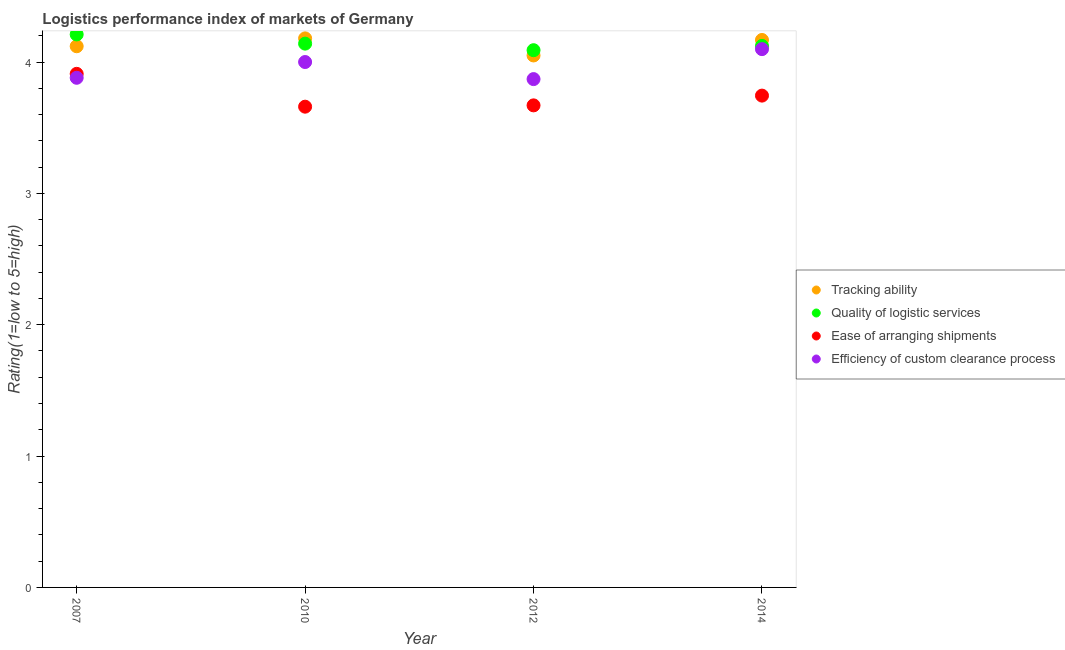Is the number of dotlines equal to the number of legend labels?
Offer a very short reply. Yes. What is the lpi rating of ease of arranging shipments in 2014?
Provide a short and direct response. 3.74. Across all years, what is the maximum lpi rating of ease of arranging shipments?
Offer a very short reply. 3.91. Across all years, what is the minimum lpi rating of ease of arranging shipments?
Make the answer very short. 3.66. In which year was the lpi rating of tracking ability minimum?
Make the answer very short. 2012. What is the total lpi rating of tracking ability in the graph?
Offer a very short reply. 16.52. What is the difference between the lpi rating of quality of logistic services in 2010 and that in 2012?
Give a very brief answer. 0.05. What is the difference between the lpi rating of ease of arranging shipments in 2007 and the lpi rating of tracking ability in 2010?
Make the answer very short. -0.27. What is the average lpi rating of quality of logistic services per year?
Give a very brief answer. 4.14. In the year 2012, what is the difference between the lpi rating of tracking ability and lpi rating of quality of logistic services?
Ensure brevity in your answer.  -0.04. What is the ratio of the lpi rating of ease of arranging shipments in 2007 to that in 2012?
Your answer should be very brief. 1.07. Is the difference between the lpi rating of efficiency of custom clearance process in 2007 and 2010 greater than the difference between the lpi rating of tracking ability in 2007 and 2010?
Provide a short and direct response. No. What is the difference between the highest and the second highest lpi rating of quality of logistic services?
Give a very brief answer. 0.07. What is the difference between the highest and the lowest lpi rating of quality of logistic services?
Your response must be concise. 0.12. In how many years, is the lpi rating of tracking ability greater than the average lpi rating of tracking ability taken over all years?
Make the answer very short. 2. Is the sum of the lpi rating of ease of arranging shipments in 2010 and 2014 greater than the maximum lpi rating of efficiency of custom clearance process across all years?
Provide a short and direct response. Yes. Is it the case that in every year, the sum of the lpi rating of tracking ability and lpi rating of quality of logistic services is greater than the lpi rating of ease of arranging shipments?
Make the answer very short. Yes. Does the lpi rating of ease of arranging shipments monotonically increase over the years?
Provide a succinct answer. No. How many dotlines are there?
Your answer should be very brief. 4. What is the difference between two consecutive major ticks on the Y-axis?
Keep it short and to the point. 1. Does the graph contain any zero values?
Give a very brief answer. No. Where does the legend appear in the graph?
Make the answer very short. Center right. How many legend labels are there?
Offer a very short reply. 4. How are the legend labels stacked?
Ensure brevity in your answer.  Vertical. What is the title of the graph?
Give a very brief answer. Logistics performance index of markets of Germany. What is the label or title of the Y-axis?
Provide a short and direct response. Rating(1=low to 5=high). What is the Rating(1=low to 5=high) of Tracking ability in 2007?
Offer a very short reply. 4.12. What is the Rating(1=low to 5=high) in Quality of logistic services in 2007?
Your answer should be very brief. 4.21. What is the Rating(1=low to 5=high) of Ease of arranging shipments in 2007?
Your answer should be very brief. 3.91. What is the Rating(1=low to 5=high) in Efficiency of custom clearance process in 2007?
Give a very brief answer. 3.88. What is the Rating(1=low to 5=high) of Tracking ability in 2010?
Provide a succinct answer. 4.18. What is the Rating(1=low to 5=high) in Quality of logistic services in 2010?
Offer a terse response. 4.14. What is the Rating(1=low to 5=high) in Ease of arranging shipments in 2010?
Make the answer very short. 3.66. What is the Rating(1=low to 5=high) of Tracking ability in 2012?
Your answer should be compact. 4.05. What is the Rating(1=low to 5=high) of Quality of logistic services in 2012?
Provide a succinct answer. 4.09. What is the Rating(1=low to 5=high) in Ease of arranging shipments in 2012?
Ensure brevity in your answer.  3.67. What is the Rating(1=low to 5=high) of Efficiency of custom clearance process in 2012?
Provide a short and direct response. 3.87. What is the Rating(1=low to 5=high) in Tracking ability in 2014?
Ensure brevity in your answer.  4.17. What is the Rating(1=low to 5=high) of Quality of logistic services in 2014?
Provide a succinct answer. 4.12. What is the Rating(1=low to 5=high) of Ease of arranging shipments in 2014?
Make the answer very short. 3.74. What is the Rating(1=low to 5=high) of Efficiency of custom clearance process in 2014?
Give a very brief answer. 4.1. Across all years, what is the maximum Rating(1=low to 5=high) in Tracking ability?
Keep it short and to the point. 4.18. Across all years, what is the maximum Rating(1=low to 5=high) in Quality of logistic services?
Make the answer very short. 4.21. Across all years, what is the maximum Rating(1=low to 5=high) of Ease of arranging shipments?
Your response must be concise. 3.91. Across all years, what is the maximum Rating(1=low to 5=high) in Efficiency of custom clearance process?
Keep it short and to the point. 4.1. Across all years, what is the minimum Rating(1=low to 5=high) in Tracking ability?
Ensure brevity in your answer.  4.05. Across all years, what is the minimum Rating(1=low to 5=high) of Quality of logistic services?
Give a very brief answer. 4.09. Across all years, what is the minimum Rating(1=low to 5=high) of Ease of arranging shipments?
Provide a short and direct response. 3.66. Across all years, what is the minimum Rating(1=low to 5=high) in Efficiency of custom clearance process?
Ensure brevity in your answer.  3.87. What is the total Rating(1=low to 5=high) in Tracking ability in the graph?
Your answer should be compact. 16.52. What is the total Rating(1=low to 5=high) of Quality of logistic services in the graph?
Give a very brief answer. 16.56. What is the total Rating(1=low to 5=high) of Ease of arranging shipments in the graph?
Offer a terse response. 14.98. What is the total Rating(1=low to 5=high) in Efficiency of custom clearance process in the graph?
Your answer should be very brief. 15.85. What is the difference between the Rating(1=low to 5=high) of Tracking ability in 2007 and that in 2010?
Your answer should be compact. -0.06. What is the difference between the Rating(1=low to 5=high) of Quality of logistic services in 2007 and that in 2010?
Give a very brief answer. 0.07. What is the difference between the Rating(1=low to 5=high) of Ease of arranging shipments in 2007 and that in 2010?
Your answer should be compact. 0.25. What is the difference between the Rating(1=low to 5=high) of Efficiency of custom clearance process in 2007 and that in 2010?
Provide a succinct answer. -0.12. What is the difference between the Rating(1=low to 5=high) of Tracking ability in 2007 and that in 2012?
Keep it short and to the point. 0.07. What is the difference between the Rating(1=low to 5=high) in Quality of logistic services in 2007 and that in 2012?
Your answer should be very brief. 0.12. What is the difference between the Rating(1=low to 5=high) in Ease of arranging shipments in 2007 and that in 2012?
Your response must be concise. 0.24. What is the difference between the Rating(1=low to 5=high) of Efficiency of custom clearance process in 2007 and that in 2012?
Provide a short and direct response. 0.01. What is the difference between the Rating(1=low to 5=high) in Tracking ability in 2007 and that in 2014?
Provide a short and direct response. -0.05. What is the difference between the Rating(1=low to 5=high) of Quality of logistic services in 2007 and that in 2014?
Give a very brief answer. 0.09. What is the difference between the Rating(1=low to 5=high) in Ease of arranging shipments in 2007 and that in 2014?
Provide a short and direct response. 0.17. What is the difference between the Rating(1=low to 5=high) in Efficiency of custom clearance process in 2007 and that in 2014?
Make the answer very short. -0.22. What is the difference between the Rating(1=low to 5=high) in Tracking ability in 2010 and that in 2012?
Make the answer very short. 0.13. What is the difference between the Rating(1=low to 5=high) in Ease of arranging shipments in 2010 and that in 2012?
Provide a succinct answer. -0.01. What is the difference between the Rating(1=low to 5=high) of Efficiency of custom clearance process in 2010 and that in 2012?
Make the answer very short. 0.13. What is the difference between the Rating(1=low to 5=high) of Tracking ability in 2010 and that in 2014?
Make the answer very short. 0.01. What is the difference between the Rating(1=low to 5=high) in Quality of logistic services in 2010 and that in 2014?
Offer a terse response. 0.02. What is the difference between the Rating(1=low to 5=high) in Ease of arranging shipments in 2010 and that in 2014?
Keep it short and to the point. -0.08. What is the difference between the Rating(1=low to 5=high) of Efficiency of custom clearance process in 2010 and that in 2014?
Provide a short and direct response. -0.1. What is the difference between the Rating(1=low to 5=high) of Tracking ability in 2012 and that in 2014?
Provide a short and direct response. -0.12. What is the difference between the Rating(1=low to 5=high) of Quality of logistic services in 2012 and that in 2014?
Your answer should be compact. -0.03. What is the difference between the Rating(1=low to 5=high) in Ease of arranging shipments in 2012 and that in 2014?
Make the answer very short. -0.07. What is the difference between the Rating(1=low to 5=high) in Efficiency of custom clearance process in 2012 and that in 2014?
Offer a terse response. -0.23. What is the difference between the Rating(1=low to 5=high) in Tracking ability in 2007 and the Rating(1=low to 5=high) in Quality of logistic services in 2010?
Your response must be concise. -0.02. What is the difference between the Rating(1=low to 5=high) of Tracking ability in 2007 and the Rating(1=low to 5=high) of Ease of arranging shipments in 2010?
Your response must be concise. 0.46. What is the difference between the Rating(1=low to 5=high) in Tracking ability in 2007 and the Rating(1=low to 5=high) in Efficiency of custom clearance process in 2010?
Your answer should be very brief. 0.12. What is the difference between the Rating(1=low to 5=high) in Quality of logistic services in 2007 and the Rating(1=low to 5=high) in Ease of arranging shipments in 2010?
Offer a terse response. 0.55. What is the difference between the Rating(1=low to 5=high) of Quality of logistic services in 2007 and the Rating(1=low to 5=high) of Efficiency of custom clearance process in 2010?
Provide a succinct answer. 0.21. What is the difference between the Rating(1=low to 5=high) of Ease of arranging shipments in 2007 and the Rating(1=low to 5=high) of Efficiency of custom clearance process in 2010?
Your answer should be compact. -0.09. What is the difference between the Rating(1=low to 5=high) in Tracking ability in 2007 and the Rating(1=low to 5=high) in Ease of arranging shipments in 2012?
Your response must be concise. 0.45. What is the difference between the Rating(1=low to 5=high) in Tracking ability in 2007 and the Rating(1=low to 5=high) in Efficiency of custom clearance process in 2012?
Keep it short and to the point. 0.25. What is the difference between the Rating(1=low to 5=high) in Quality of logistic services in 2007 and the Rating(1=low to 5=high) in Ease of arranging shipments in 2012?
Offer a terse response. 0.54. What is the difference between the Rating(1=low to 5=high) in Quality of logistic services in 2007 and the Rating(1=low to 5=high) in Efficiency of custom clearance process in 2012?
Provide a short and direct response. 0.34. What is the difference between the Rating(1=low to 5=high) in Tracking ability in 2007 and the Rating(1=low to 5=high) in Quality of logistic services in 2014?
Keep it short and to the point. -0. What is the difference between the Rating(1=low to 5=high) in Tracking ability in 2007 and the Rating(1=low to 5=high) in Ease of arranging shipments in 2014?
Your answer should be very brief. 0.38. What is the difference between the Rating(1=low to 5=high) in Tracking ability in 2007 and the Rating(1=low to 5=high) in Efficiency of custom clearance process in 2014?
Offer a terse response. 0.02. What is the difference between the Rating(1=low to 5=high) in Quality of logistic services in 2007 and the Rating(1=low to 5=high) in Ease of arranging shipments in 2014?
Provide a short and direct response. 0.47. What is the difference between the Rating(1=low to 5=high) of Quality of logistic services in 2007 and the Rating(1=low to 5=high) of Efficiency of custom clearance process in 2014?
Provide a short and direct response. 0.11. What is the difference between the Rating(1=low to 5=high) in Ease of arranging shipments in 2007 and the Rating(1=low to 5=high) in Efficiency of custom clearance process in 2014?
Give a very brief answer. -0.19. What is the difference between the Rating(1=low to 5=high) in Tracking ability in 2010 and the Rating(1=low to 5=high) in Quality of logistic services in 2012?
Make the answer very short. 0.09. What is the difference between the Rating(1=low to 5=high) in Tracking ability in 2010 and the Rating(1=low to 5=high) in Ease of arranging shipments in 2012?
Offer a very short reply. 0.51. What is the difference between the Rating(1=low to 5=high) of Tracking ability in 2010 and the Rating(1=low to 5=high) of Efficiency of custom clearance process in 2012?
Your answer should be compact. 0.31. What is the difference between the Rating(1=low to 5=high) of Quality of logistic services in 2010 and the Rating(1=low to 5=high) of Ease of arranging shipments in 2012?
Your answer should be very brief. 0.47. What is the difference between the Rating(1=low to 5=high) of Quality of logistic services in 2010 and the Rating(1=low to 5=high) of Efficiency of custom clearance process in 2012?
Keep it short and to the point. 0.27. What is the difference between the Rating(1=low to 5=high) of Ease of arranging shipments in 2010 and the Rating(1=low to 5=high) of Efficiency of custom clearance process in 2012?
Make the answer very short. -0.21. What is the difference between the Rating(1=low to 5=high) of Tracking ability in 2010 and the Rating(1=low to 5=high) of Quality of logistic services in 2014?
Provide a short and direct response. 0.06. What is the difference between the Rating(1=low to 5=high) of Tracking ability in 2010 and the Rating(1=low to 5=high) of Ease of arranging shipments in 2014?
Ensure brevity in your answer.  0.44. What is the difference between the Rating(1=low to 5=high) in Tracking ability in 2010 and the Rating(1=low to 5=high) in Efficiency of custom clearance process in 2014?
Your answer should be very brief. 0.08. What is the difference between the Rating(1=low to 5=high) in Quality of logistic services in 2010 and the Rating(1=low to 5=high) in Ease of arranging shipments in 2014?
Provide a short and direct response. 0.4. What is the difference between the Rating(1=low to 5=high) of Quality of logistic services in 2010 and the Rating(1=low to 5=high) of Efficiency of custom clearance process in 2014?
Make the answer very short. 0.04. What is the difference between the Rating(1=low to 5=high) of Ease of arranging shipments in 2010 and the Rating(1=low to 5=high) of Efficiency of custom clearance process in 2014?
Give a very brief answer. -0.44. What is the difference between the Rating(1=low to 5=high) in Tracking ability in 2012 and the Rating(1=low to 5=high) in Quality of logistic services in 2014?
Keep it short and to the point. -0.07. What is the difference between the Rating(1=low to 5=high) in Tracking ability in 2012 and the Rating(1=low to 5=high) in Ease of arranging shipments in 2014?
Offer a terse response. 0.31. What is the difference between the Rating(1=low to 5=high) in Tracking ability in 2012 and the Rating(1=low to 5=high) in Efficiency of custom clearance process in 2014?
Give a very brief answer. -0.05. What is the difference between the Rating(1=low to 5=high) of Quality of logistic services in 2012 and the Rating(1=low to 5=high) of Ease of arranging shipments in 2014?
Offer a very short reply. 0.35. What is the difference between the Rating(1=low to 5=high) in Quality of logistic services in 2012 and the Rating(1=low to 5=high) in Efficiency of custom clearance process in 2014?
Ensure brevity in your answer.  -0.01. What is the difference between the Rating(1=low to 5=high) in Ease of arranging shipments in 2012 and the Rating(1=low to 5=high) in Efficiency of custom clearance process in 2014?
Provide a short and direct response. -0.43. What is the average Rating(1=low to 5=high) of Tracking ability per year?
Your response must be concise. 4.13. What is the average Rating(1=low to 5=high) of Quality of logistic services per year?
Your answer should be compact. 4.14. What is the average Rating(1=low to 5=high) in Ease of arranging shipments per year?
Provide a short and direct response. 3.75. What is the average Rating(1=low to 5=high) of Efficiency of custom clearance process per year?
Make the answer very short. 3.96. In the year 2007, what is the difference between the Rating(1=low to 5=high) of Tracking ability and Rating(1=low to 5=high) of Quality of logistic services?
Ensure brevity in your answer.  -0.09. In the year 2007, what is the difference between the Rating(1=low to 5=high) of Tracking ability and Rating(1=low to 5=high) of Ease of arranging shipments?
Offer a terse response. 0.21. In the year 2007, what is the difference between the Rating(1=low to 5=high) of Tracking ability and Rating(1=low to 5=high) of Efficiency of custom clearance process?
Make the answer very short. 0.24. In the year 2007, what is the difference between the Rating(1=low to 5=high) of Quality of logistic services and Rating(1=low to 5=high) of Ease of arranging shipments?
Ensure brevity in your answer.  0.3. In the year 2007, what is the difference between the Rating(1=low to 5=high) of Quality of logistic services and Rating(1=low to 5=high) of Efficiency of custom clearance process?
Your answer should be very brief. 0.33. In the year 2010, what is the difference between the Rating(1=low to 5=high) in Tracking ability and Rating(1=low to 5=high) in Ease of arranging shipments?
Offer a terse response. 0.52. In the year 2010, what is the difference between the Rating(1=low to 5=high) of Tracking ability and Rating(1=low to 5=high) of Efficiency of custom clearance process?
Offer a terse response. 0.18. In the year 2010, what is the difference between the Rating(1=low to 5=high) of Quality of logistic services and Rating(1=low to 5=high) of Ease of arranging shipments?
Provide a short and direct response. 0.48. In the year 2010, what is the difference between the Rating(1=low to 5=high) of Quality of logistic services and Rating(1=low to 5=high) of Efficiency of custom clearance process?
Provide a short and direct response. 0.14. In the year 2010, what is the difference between the Rating(1=low to 5=high) in Ease of arranging shipments and Rating(1=low to 5=high) in Efficiency of custom clearance process?
Make the answer very short. -0.34. In the year 2012, what is the difference between the Rating(1=low to 5=high) of Tracking ability and Rating(1=low to 5=high) of Quality of logistic services?
Provide a short and direct response. -0.04. In the year 2012, what is the difference between the Rating(1=low to 5=high) of Tracking ability and Rating(1=low to 5=high) of Ease of arranging shipments?
Your answer should be very brief. 0.38. In the year 2012, what is the difference between the Rating(1=low to 5=high) in Tracking ability and Rating(1=low to 5=high) in Efficiency of custom clearance process?
Offer a very short reply. 0.18. In the year 2012, what is the difference between the Rating(1=low to 5=high) of Quality of logistic services and Rating(1=low to 5=high) of Ease of arranging shipments?
Give a very brief answer. 0.42. In the year 2012, what is the difference between the Rating(1=low to 5=high) in Quality of logistic services and Rating(1=low to 5=high) in Efficiency of custom clearance process?
Give a very brief answer. 0.22. In the year 2012, what is the difference between the Rating(1=low to 5=high) of Ease of arranging shipments and Rating(1=low to 5=high) of Efficiency of custom clearance process?
Your answer should be very brief. -0.2. In the year 2014, what is the difference between the Rating(1=low to 5=high) in Tracking ability and Rating(1=low to 5=high) in Quality of logistic services?
Your answer should be very brief. 0.05. In the year 2014, what is the difference between the Rating(1=low to 5=high) in Tracking ability and Rating(1=low to 5=high) in Ease of arranging shipments?
Ensure brevity in your answer.  0.42. In the year 2014, what is the difference between the Rating(1=low to 5=high) of Tracking ability and Rating(1=low to 5=high) of Efficiency of custom clearance process?
Your answer should be compact. 0.07. In the year 2014, what is the difference between the Rating(1=low to 5=high) of Quality of logistic services and Rating(1=low to 5=high) of Ease of arranging shipments?
Provide a succinct answer. 0.38. In the year 2014, what is the difference between the Rating(1=low to 5=high) in Quality of logistic services and Rating(1=low to 5=high) in Efficiency of custom clearance process?
Offer a very short reply. 0.02. In the year 2014, what is the difference between the Rating(1=low to 5=high) in Ease of arranging shipments and Rating(1=low to 5=high) in Efficiency of custom clearance process?
Provide a short and direct response. -0.35. What is the ratio of the Rating(1=low to 5=high) of Tracking ability in 2007 to that in 2010?
Make the answer very short. 0.99. What is the ratio of the Rating(1=low to 5=high) of Quality of logistic services in 2007 to that in 2010?
Your answer should be very brief. 1.02. What is the ratio of the Rating(1=low to 5=high) in Ease of arranging shipments in 2007 to that in 2010?
Make the answer very short. 1.07. What is the ratio of the Rating(1=low to 5=high) in Efficiency of custom clearance process in 2007 to that in 2010?
Your answer should be very brief. 0.97. What is the ratio of the Rating(1=low to 5=high) in Tracking ability in 2007 to that in 2012?
Ensure brevity in your answer.  1.02. What is the ratio of the Rating(1=low to 5=high) in Quality of logistic services in 2007 to that in 2012?
Make the answer very short. 1.03. What is the ratio of the Rating(1=low to 5=high) in Ease of arranging shipments in 2007 to that in 2012?
Ensure brevity in your answer.  1.07. What is the ratio of the Rating(1=low to 5=high) in Tracking ability in 2007 to that in 2014?
Your answer should be very brief. 0.99. What is the ratio of the Rating(1=low to 5=high) in Quality of logistic services in 2007 to that in 2014?
Provide a succinct answer. 1.02. What is the ratio of the Rating(1=low to 5=high) of Ease of arranging shipments in 2007 to that in 2014?
Your answer should be compact. 1.04. What is the ratio of the Rating(1=low to 5=high) in Efficiency of custom clearance process in 2007 to that in 2014?
Offer a very short reply. 0.95. What is the ratio of the Rating(1=low to 5=high) of Tracking ability in 2010 to that in 2012?
Keep it short and to the point. 1.03. What is the ratio of the Rating(1=low to 5=high) of Quality of logistic services in 2010 to that in 2012?
Keep it short and to the point. 1.01. What is the ratio of the Rating(1=low to 5=high) of Ease of arranging shipments in 2010 to that in 2012?
Keep it short and to the point. 1. What is the ratio of the Rating(1=low to 5=high) of Efficiency of custom clearance process in 2010 to that in 2012?
Your answer should be very brief. 1.03. What is the ratio of the Rating(1=low to 5=high) in Ease of arranging shipments in 2010 to that in 2014?
Your answer should be very brief. 0.98. What is the ratio of the Rating(1=low to 5=high) in Efficiency of custom clearance process in 2010 to that in 2014?
Give a very brief answer. 0.98. What is the ratio of the Rating(1=low to 5=high) in Tracking ability in 2012 to that in 2014?
Provide a short and direct response. 0.97. What is the ratio of the Rating(1=low to 5=high) in Ease of arranging shipments in 2012 to that in 2014?
Give a very brief answer. 0.98. What is the ratio of the Rating(1=low to 5=high) in Efficiency of custom clearance process in 2012 to that in 2014?
Your response must be concise. 0.94. What is the difference between the highest and the second highest Rating(1=low to 5=high) of Tracking ability?
Offer a very short reply. 0.01. What is the difference between the highest and the second highest Rating(1=low to 5=high) in Quality of logistic services?
Your answer should be very brief. 0.07. What is the difference between the highest and the second highest Rating(1=low to 5=high) in Ease of arranging shipments?
Provide a short and direct response. 0.17. What is the difference between the highest and the second highest Rating(1=low to 5=high) in Efficiency of custom clearance process?
Keep it short and to the point. 0.1. What is the difference between the highest and the lowest Rating(1=low to 5=high) of Tracking ability?
Your response must be concise. 0.13. What is the difference between the highest and the lowest Rating(1=low to 5=high) of Quality of logistic services?
Offer a terse response. 0.12. What is the difference between the highest and the lowest Rating(1=low to 5=high) of Ease of arranging shipments?
Your answer should be very brief. 0.25. What is the difference between the highest and the lowest Rating(1=low to 5=high) of Efficiency of custom clearance process?
Your response must be concise. 0.23. 